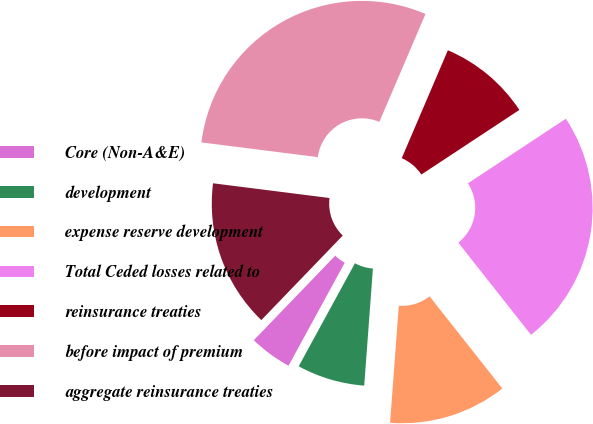Convert chart to OTSL. <chart><loc_0><loc_0><loc_500><loc_500><pie_chart><fcel>Core (Non-A&E)<fcel>development<fcel>expense reserve development<fcel>Total Ceded losses related to<fcel>reinsurance treaties<fcel>before impact of premium<fcel>aggregate reinsurance treaties<nl><fcel>4.25%<fcel>6.77%<fcel>11.81%<fcel>23.65%<fcel>9.29%<fcel>29.43%<fcel>14.8%<nl></chart> 